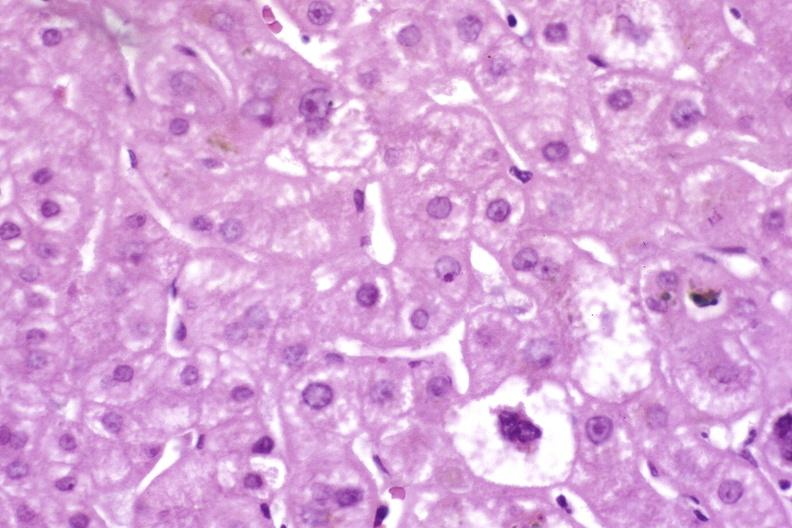what does this image show?
Answer the question using a single word or phrase. Resolving acute rejection 